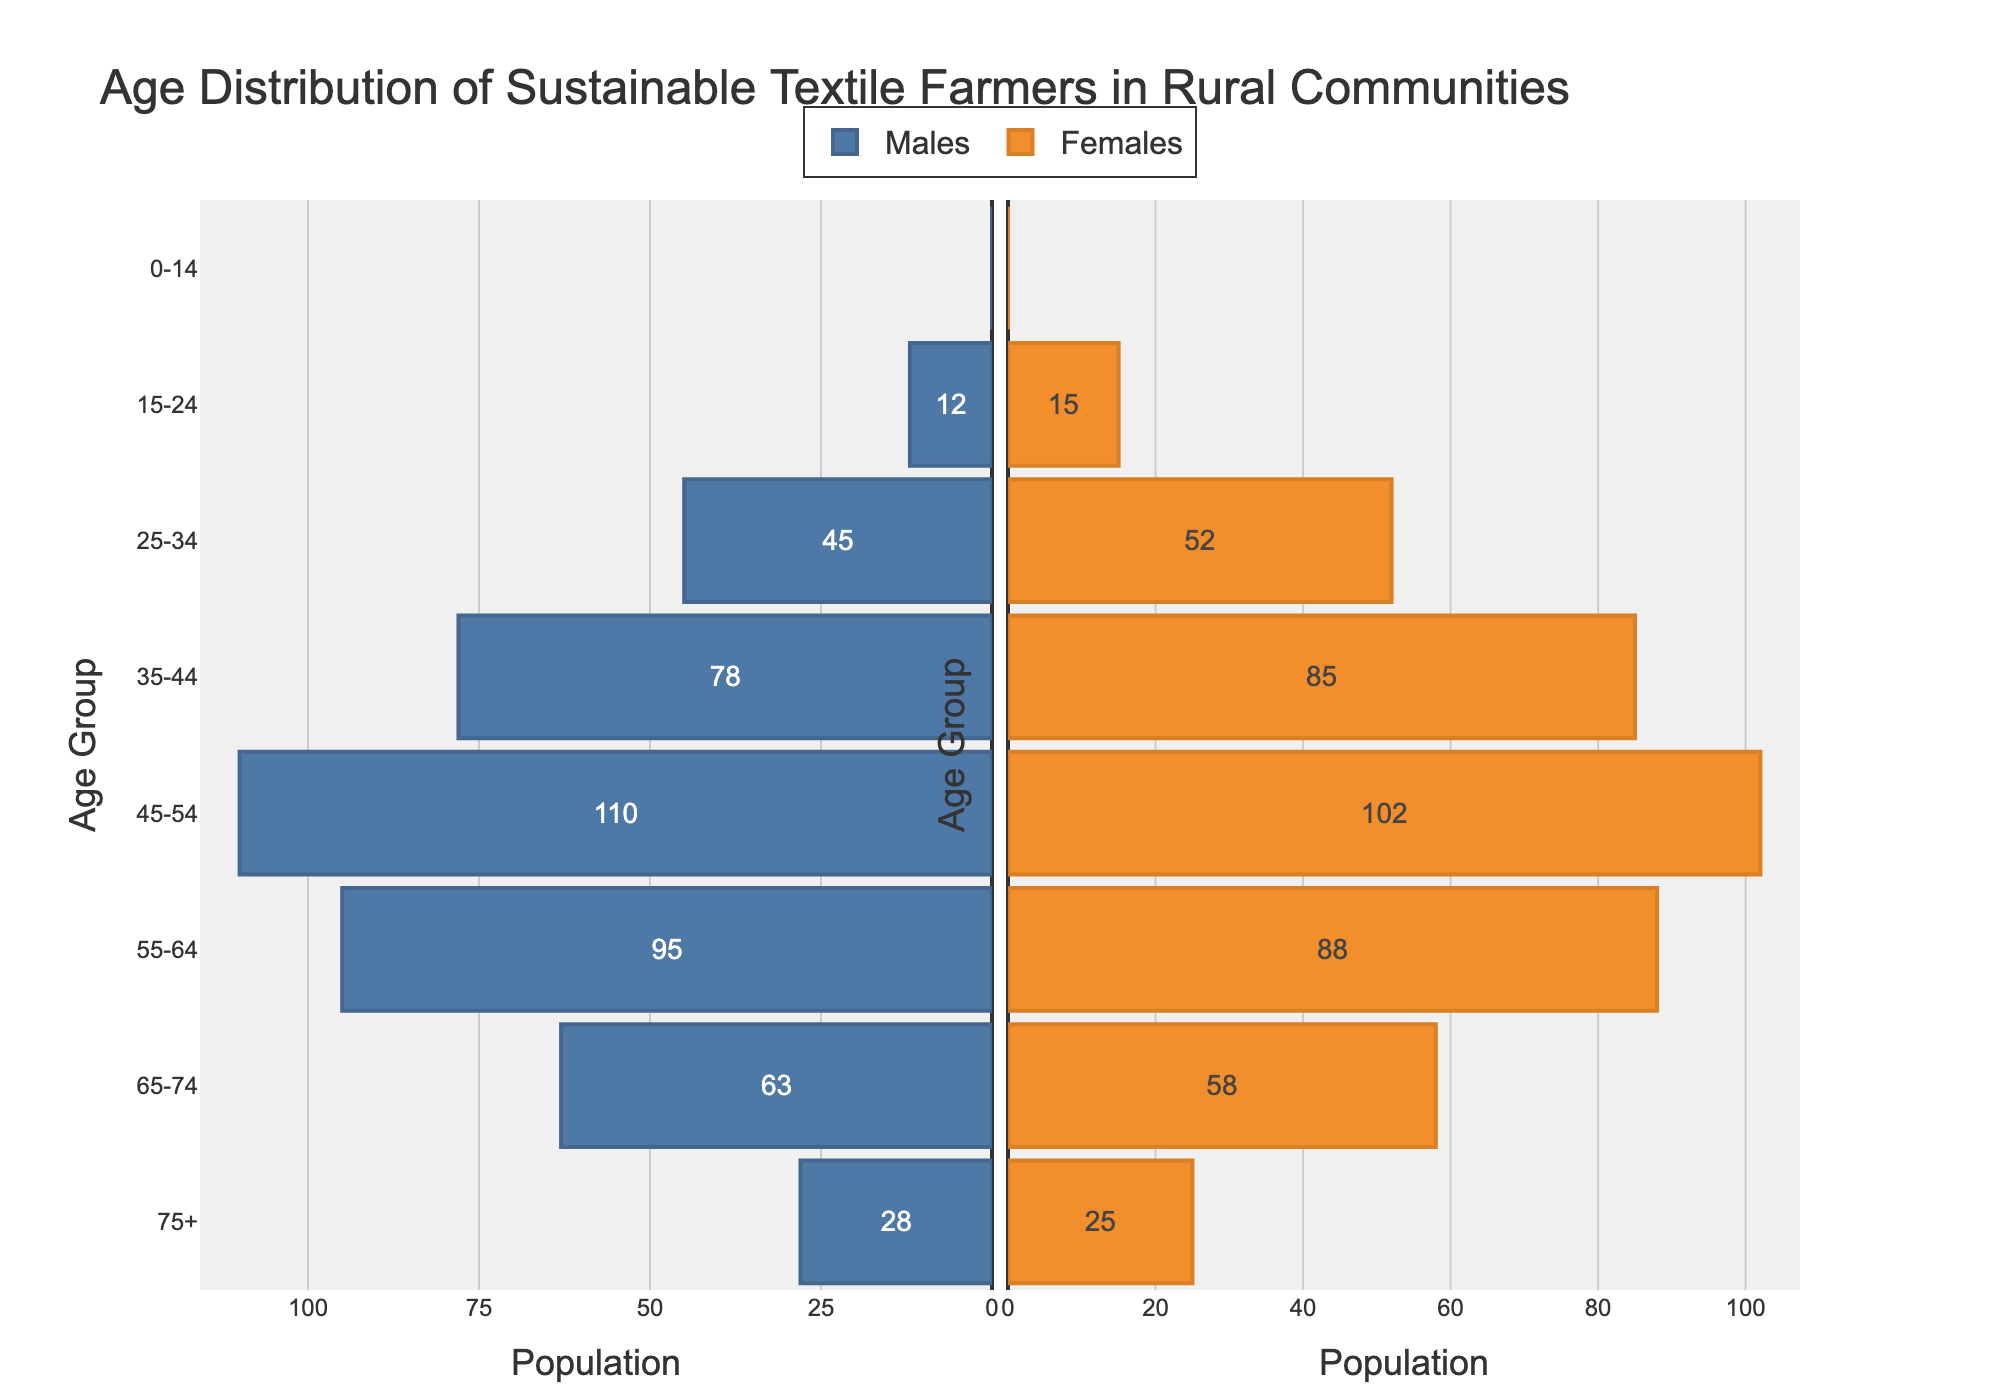What is the title of the figure? The title is typically placed at the top of the figure. It provides a summary of what the figure represents. The title is "Age Distribution of Sustainable Textile Farmers in Rural Communities".
Answer: Age Distribution of Sustainable Textile Farmers in Rural Communities How many age groups are there in the figure? Count the unique age categories listed on the y-axis. There are 8 distinct age categories from "0-14" to "75+".
Answer: 8 Which age group has the highest number of females? Look for the longest female bar on the right side of the figure and identify its corresponding age group. The age group "35-44" has the highest number of females.
Answer: 35-44 What is the population of males in the age group "45-54"? Locate the bar representing males for the age group "45-54". The value is represented by the length of the bar which is 110.
Answer: 110 Are there any children aged 0-14 years involved in sustainable textile farming? Check the lengths of bars corresponding to the age group "0-14" for both males and females. Both bars are at zero length.
Answer: No What is the total population of farmers aged 55-64 years? Sum the number of males and females in the age group "55-64". This is calculated as 95 (males) + 88 (females) = 183.
Answer: 183 Compare the population of males and females in the age group "75+". Who are more? Compare the lengths of the bars representing males and females in "75+". Males are represented as 28 and females as 25. Males are more.
Answer: Males What is the average number of females in the age groups "45-54" and "55-64"? Calculate the average by adding the values for females in "45-54" and "55-64" and then dividing by 2. This is (102 + 88) / 2 = 95.
Answer: 95 Which gender has a higher population in the age group "25-34"? Compare the lengths of the bars for males and females in "25-34". There are 45 males and 52 females. Females have a higher population.
Answer: Females Between the age groups "35-44" and "45-54", which group has a higher combined population for both genders? Calculate the total for each group individually and compare. "35-44" group: 78 (males) + 85 (females) = 163. "45-54" group: 110 (males) + 102 (females) = 212. The "45-54" group has a higher combined population.
Answer: 45-54 